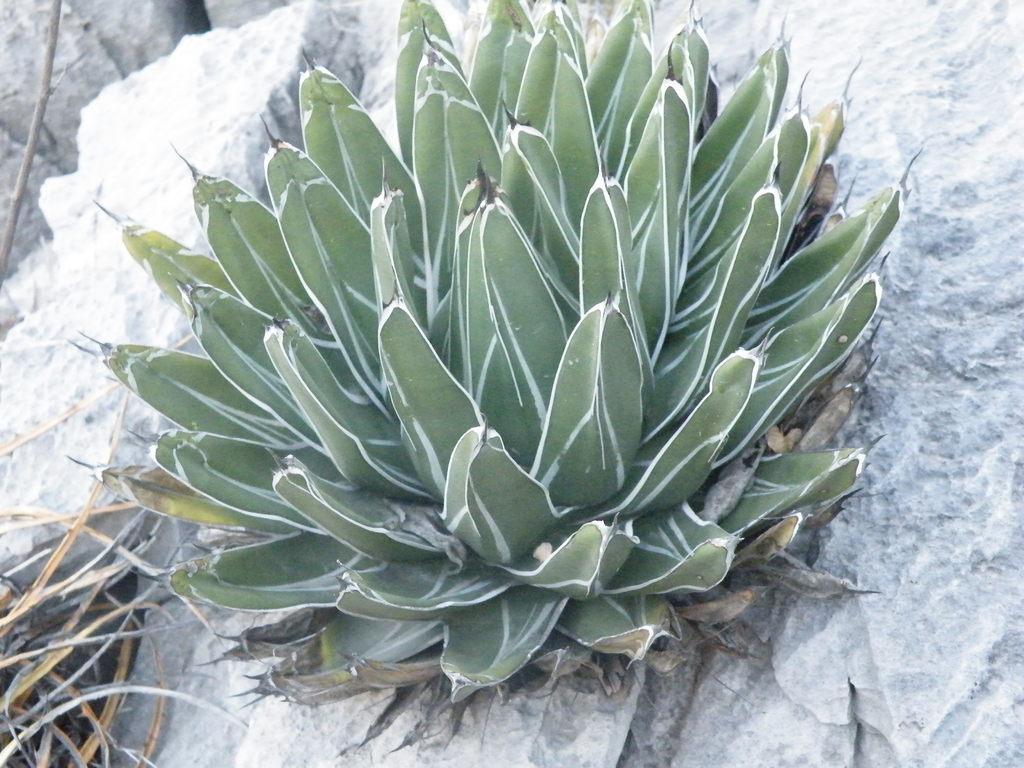Describe this image in one or two sentences. In this picture there is agave plant in the center of the image. 